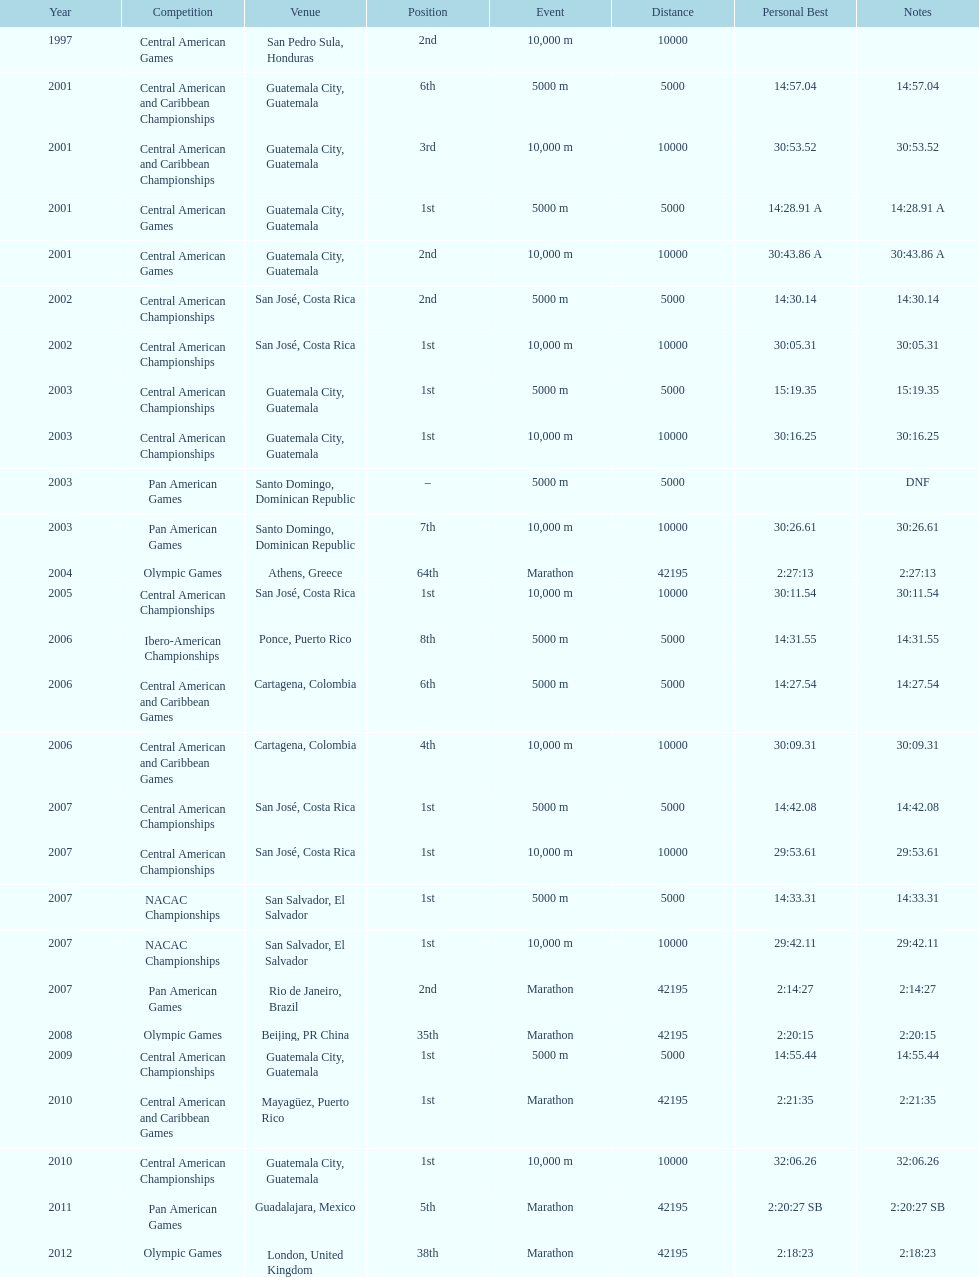Where was the only 64th position held? Athens, Greece. 